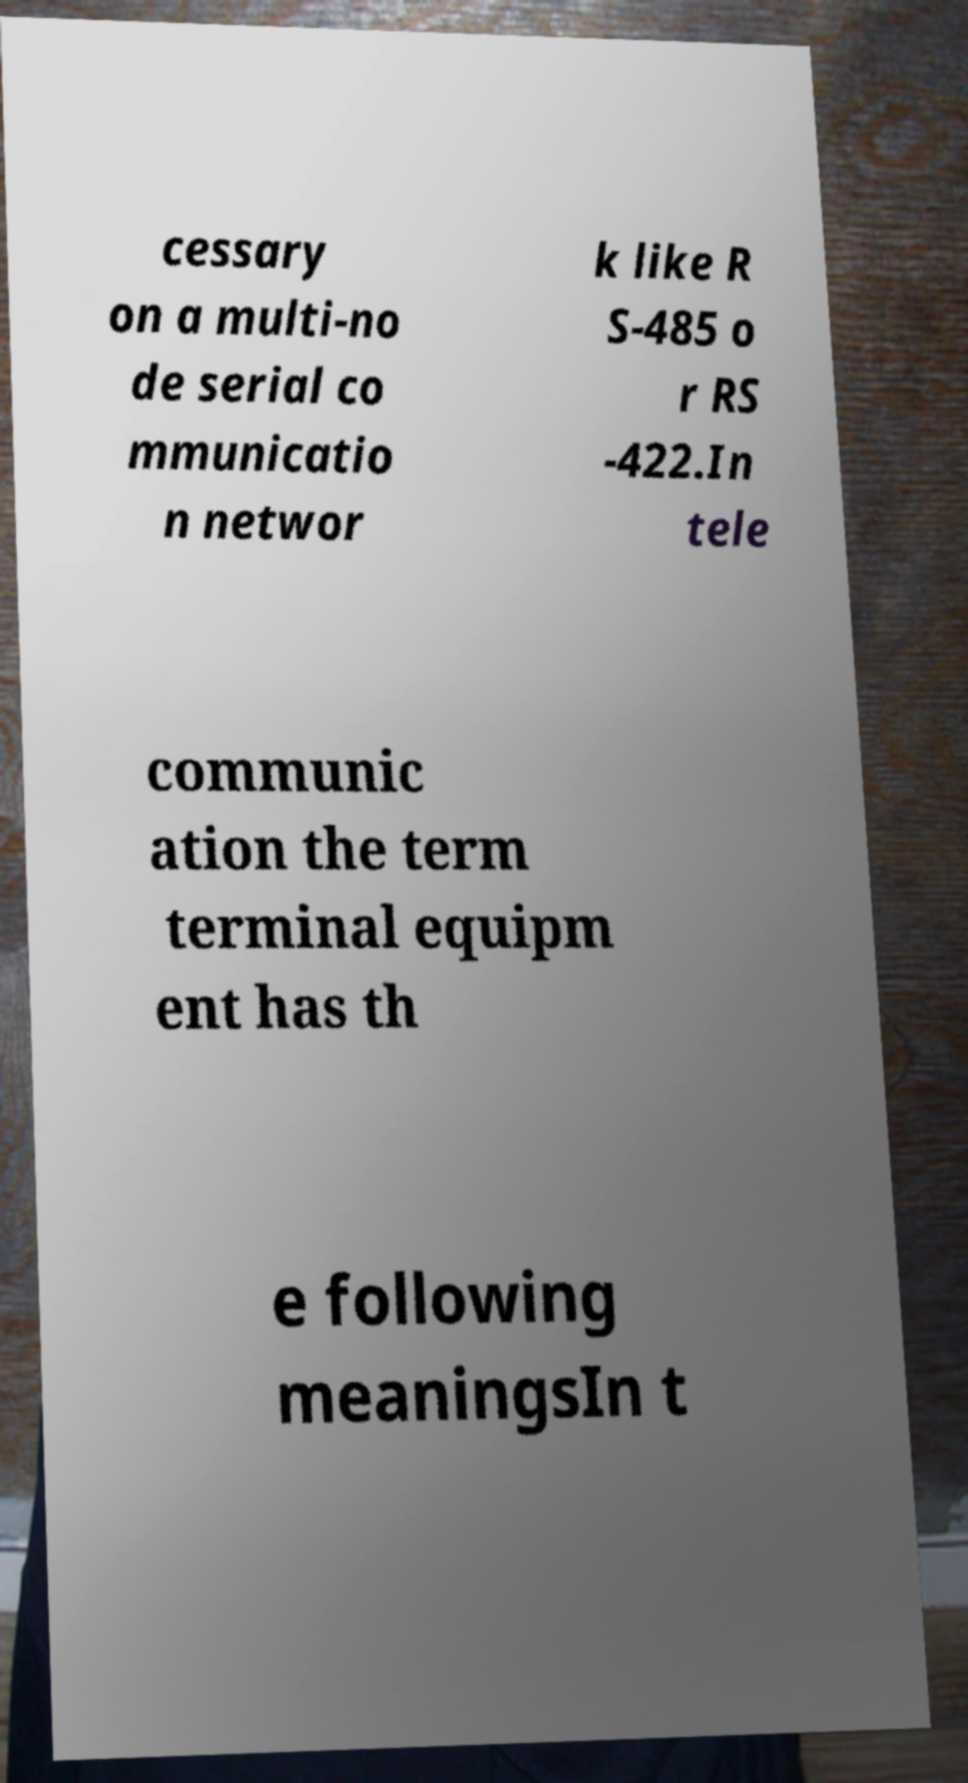Can you read and provide the text displayed in the image?This photo seems to have some interesting text. Can you extract and type it out for me? cessary on a multi-no de serial co mmunicatio n networ k like R S-485 o r RS -422.In tele communic ation the term terminal equipm ent has th e following meaningsIn t 